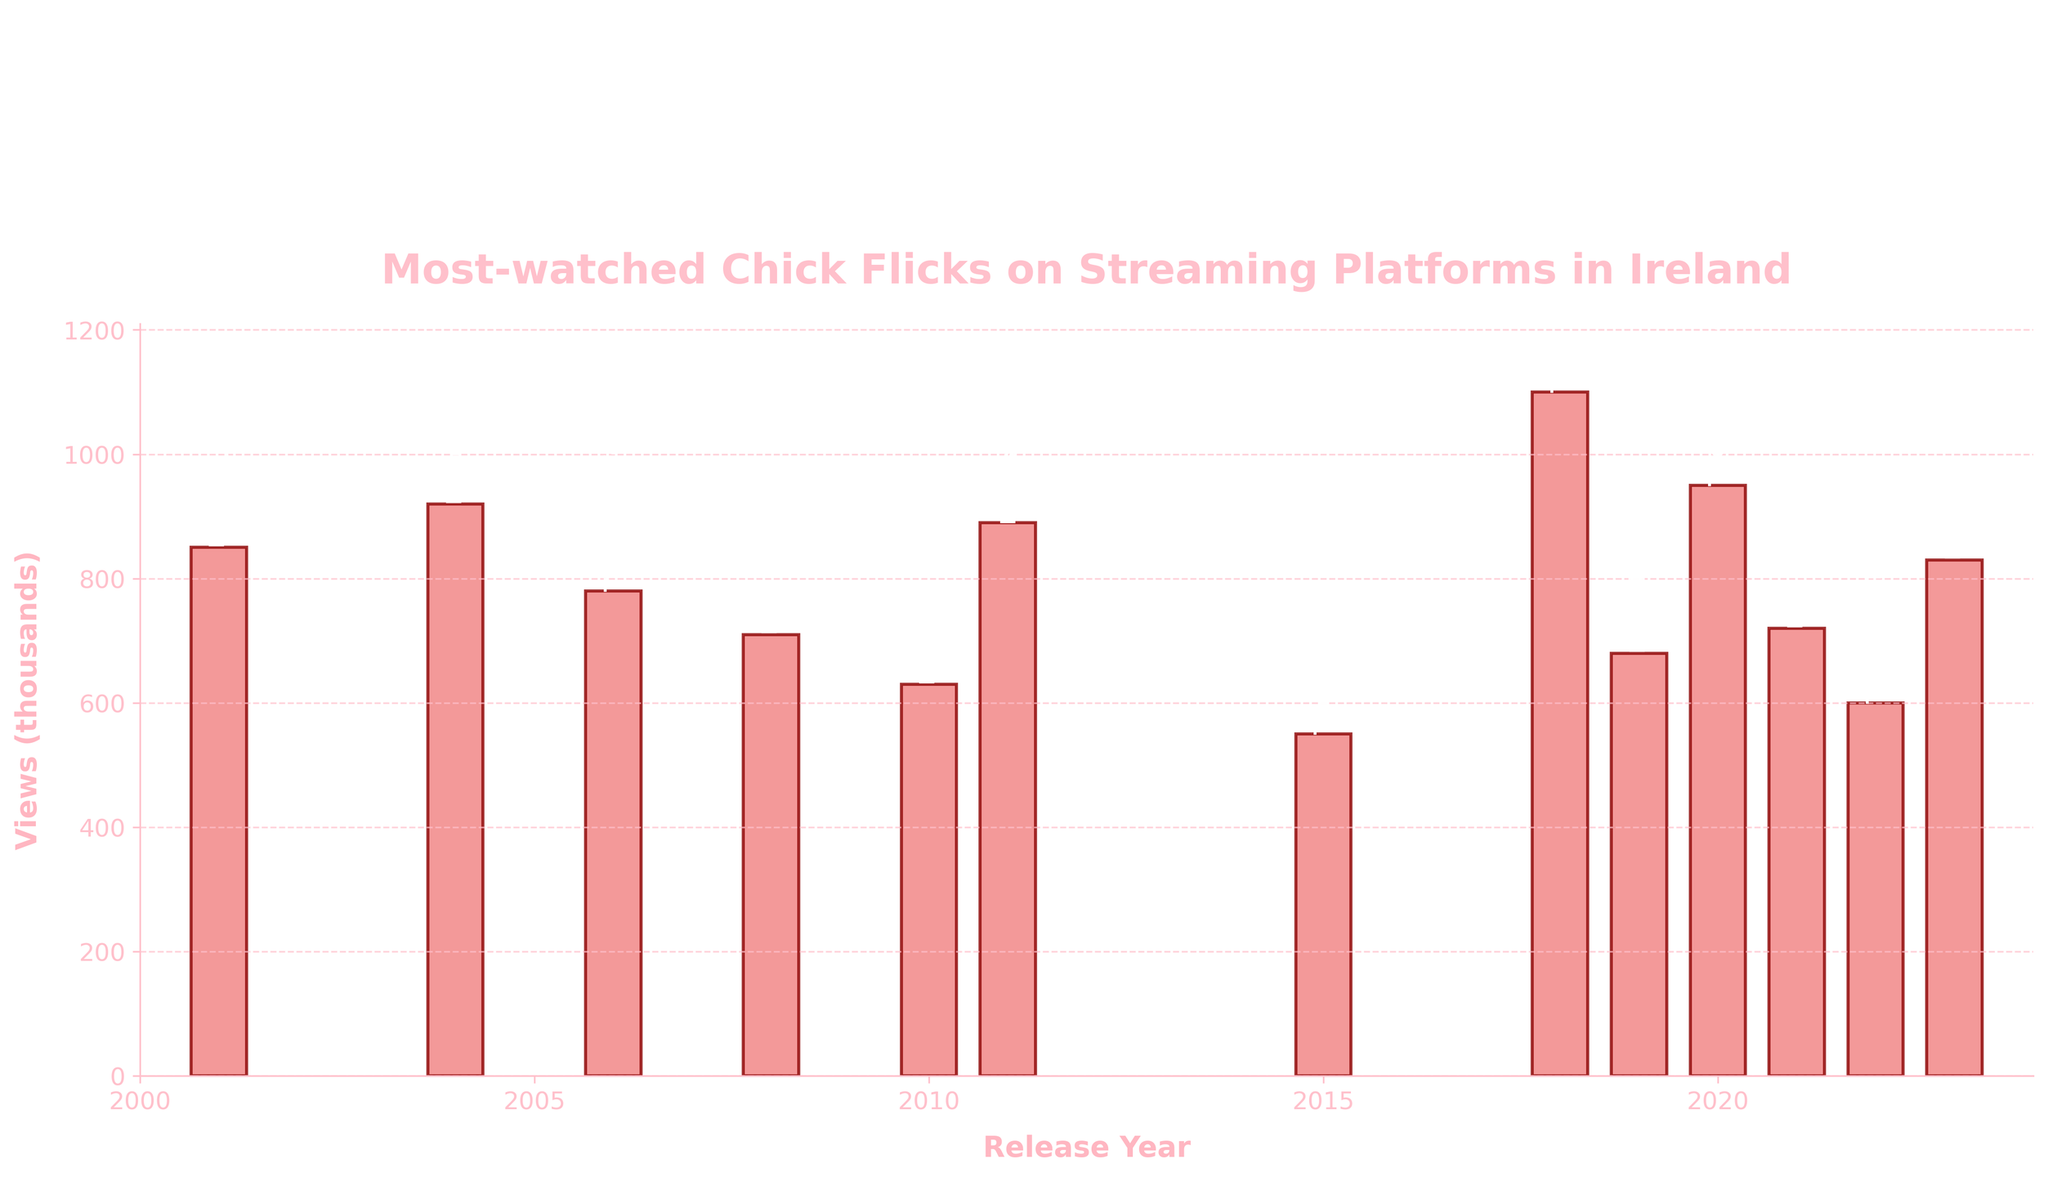Which chick flick has the highest number of views in the data? Look at the height of the bars; the highest bar corresponds to "To All the Boys I've Loved Before" with 1100 thousand views.
Answer: To All the Boys I've Loved Before Which movie released in 2015 has the lowest views? Find the bar corresponding to the year 2015; it is labeled "The Duff" with 550 thousand views.
Answer: The Duff How much more views does "Bridget Jones's Diary" have compared to "Bridesmaids"? Compare the heights of the bars for these two movies; "Bridget Jones's Diary" has 850 thousand views, and "Bridesmaids" has 890 thousand views. Calculate 890 - 850.
Answer: 40 thousand What is the average number of views for movies released from 2018 to 2023? Identify the relevant movies and their views: 1100, 680, 950, 720, 600, 830. Sum these values: 1100 + 680 + 950 + 720 + 600 + 830 = 4880. There are 6 movies, so divide by 6.
Answer: 813.33 thousand Which movie released after 2015 has the least number of views? Check bars for years after 2015. The lowest of these are for "The Royal Treatment" in 2022 with 600 thousand views.
Answer: The Royal Treatment Which years have multiple movies listed and what are the views for those movies? Review bars and note years with multiple movies: 2018, 2019, 2020, 2021, 2022 and 2023. Their views are: 2018 (1100), 2019 (680), 2020 (950), 2021 (720), 2022 (600), 2023 (830).
Answer: 2018 (1100 thousand), 2019 (680 thousand), 2020 (950 thousand), 2021 (720 thousand), 2022 (600 thousand), 2023 (830 thousand) Among "The Devil Wears Prada", "Easy A", and "The Kissing Booth 2", which one has the highest views and by how much? Compare the views of these three movies: 780, 630, and 950 thousand. The highest is "The Kissing Booth 2" with 950 thousand. The second-highest is "The Devil Wears Prada" with 780 thousand. Calculate 950 - 780.
Answer: The Kissing Booth 2 by 170 thousand Which year saw the movie with the second-highest number of views and what's the title of this movie? Find the bars with the highest views; the second-highest bar corresponds to the year 2020, labeled "The Kissing Booth 2" with 950 thousand views.
Answer: 2020, The Kissing Booth 2 